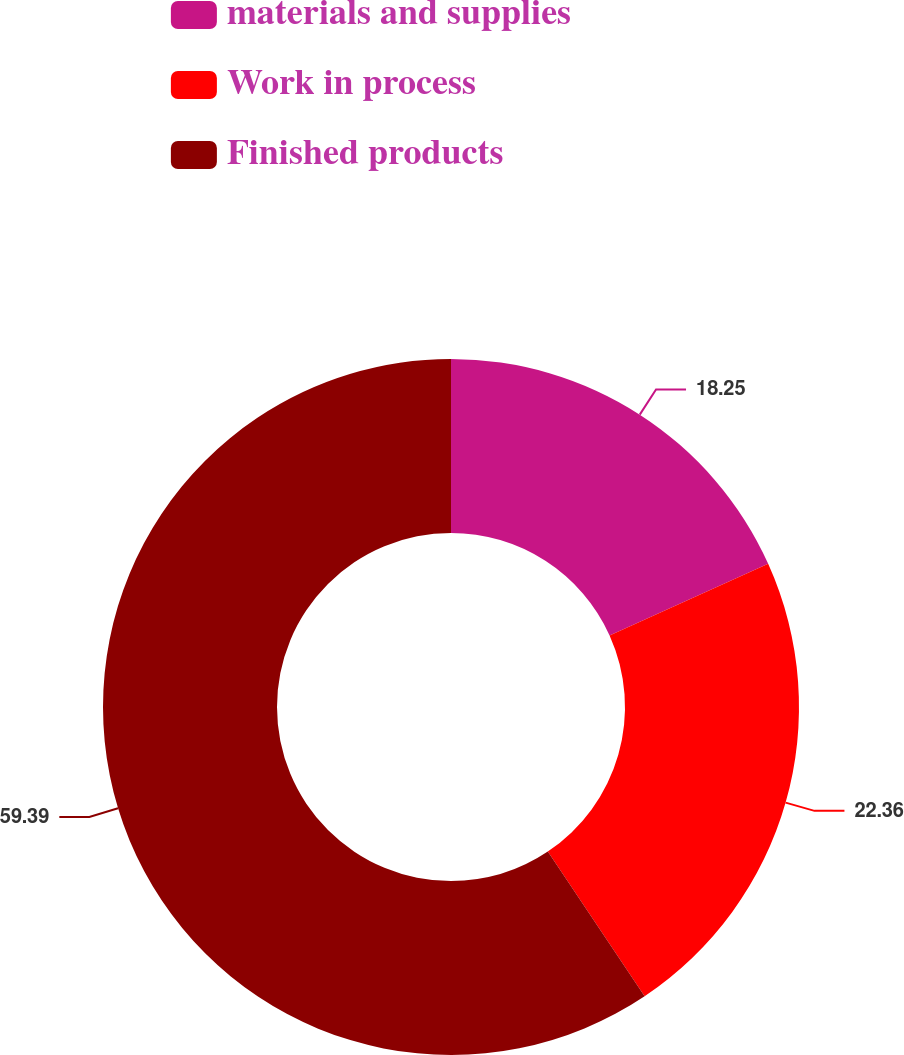<chart> <loc_0><loc_0><loc_500><loc_500><pie_chart><fcel>materials and supplies<fcel>Work in process<fcel>Finished products<nl><fcel>18.25%<fcel>22.36%<fcel>59.39%<nl></chart> 